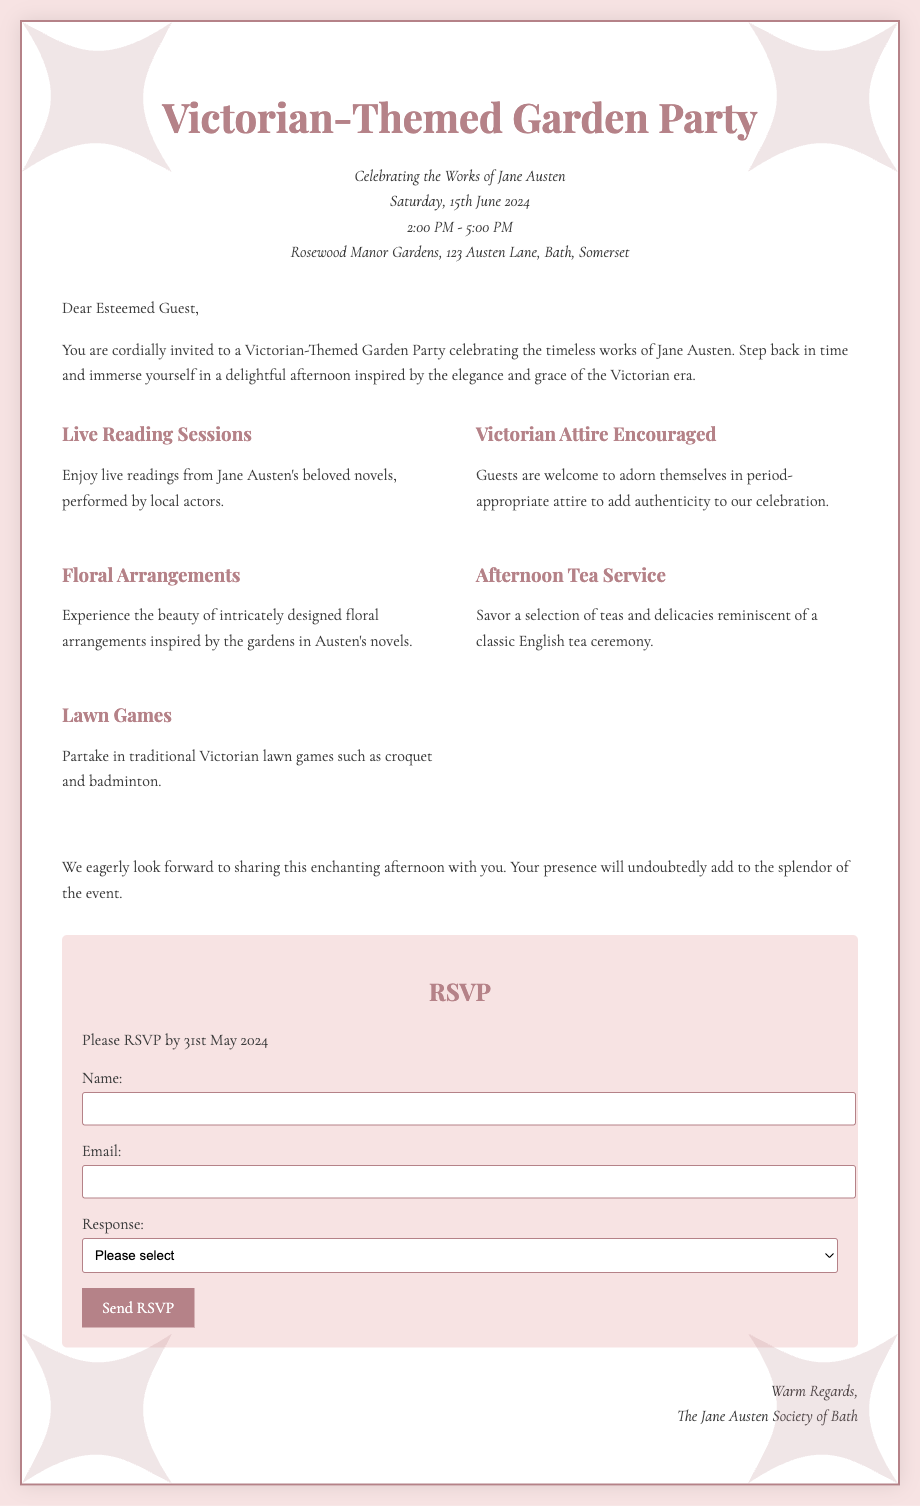What is the date of the event? The document specifies that the event will take place on Saturday, 15th June 2024.
Answer: 15th June 2024 What is the time of the garden party? The party is scheduled to occur from 2:00 PM to 5:00 PM, as mentioned in the event details.
Answer: 2:00 PM - 5:00 PM What type of attire is encouraged for guests? The document states that Victorian attire is encouraged, adding authenticity to the celebration.
Answer: Victorian Attire Who is hosting the event? The signature at the bottom of the document indicates that the event is hosted by The Jane Austen Society of Bath.
Answer: The Jane Austen Society of Bath What floral features are mentioned in the highlights? The highlights mention intricately designed floral arrangements inspired by the gardens in Austen's novels.
Answer: Floral Arrangements By what date should guests RSVP? The RSVP section of the document specifies that guests should respond by 31st May 2024.
Answer: 31st May 2024 What is one of the activities at the party? The highlights list lawn games among the activities, specifically mentioning croquet and badminton as traditional Victorian games.
Answer: Lawn Games What should a guest select in the response section if they plan to attend? Guests who plan to attend should select "Joyfully accept" in the response section of the RSVP.
Answer: Joyfully accept 